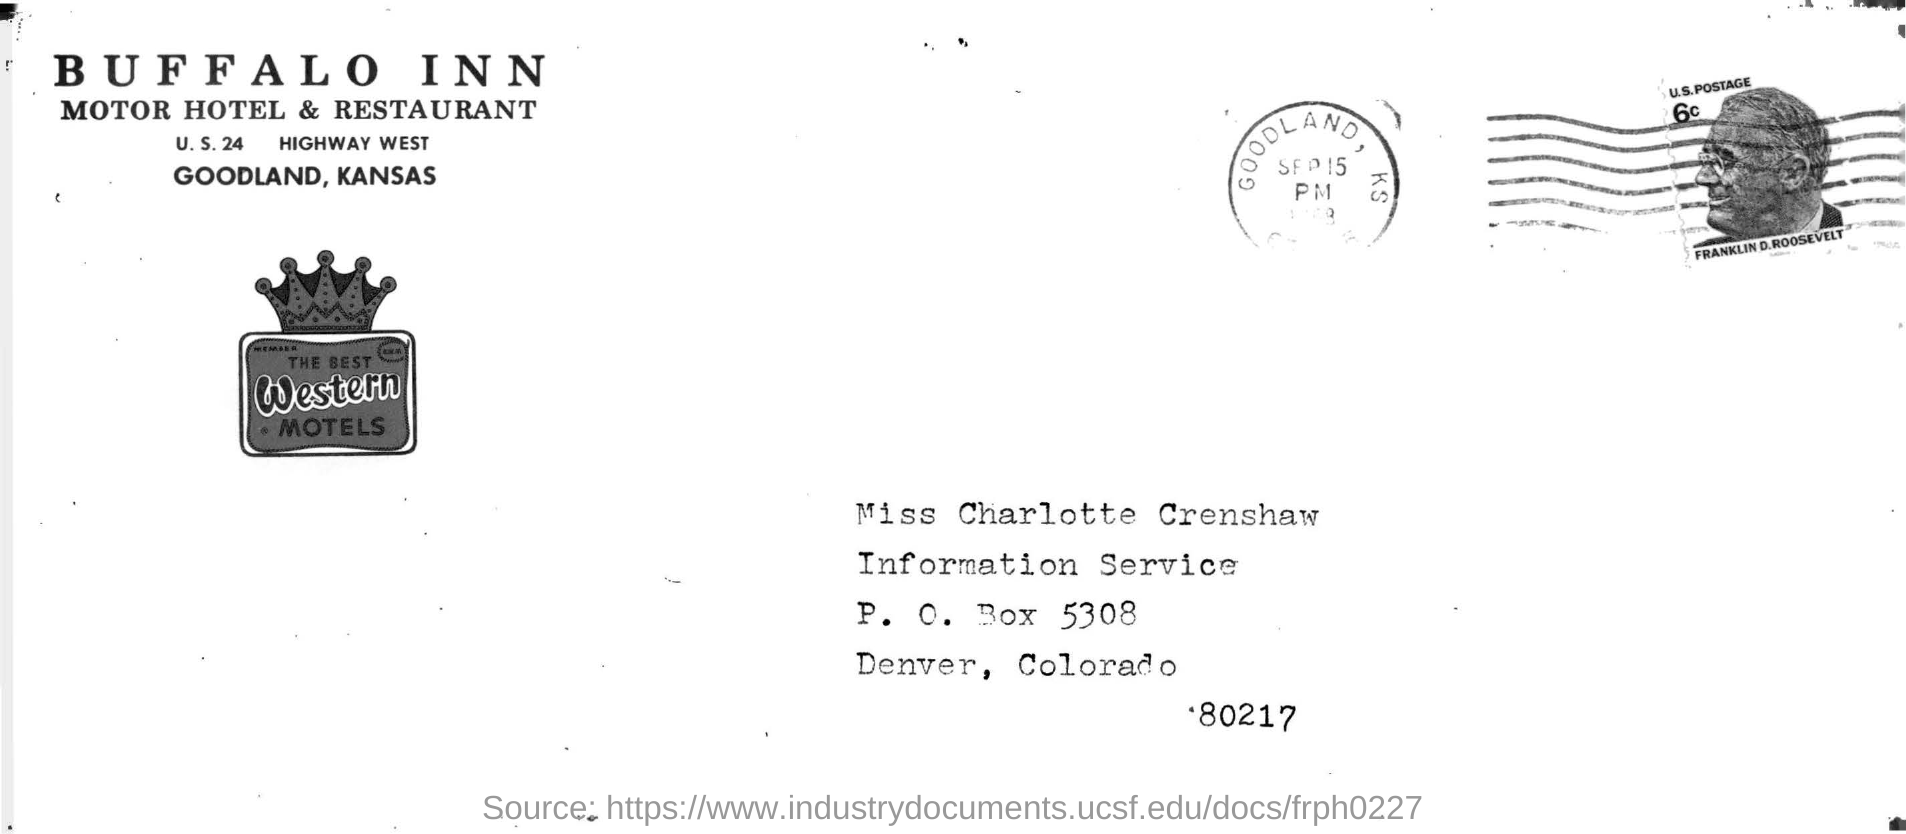Identify some key points in this picture. The Buffalo Inn Motor Hotel and Restaurant is located in Kansas. The name of the hotel is the Buffalo Inn. 